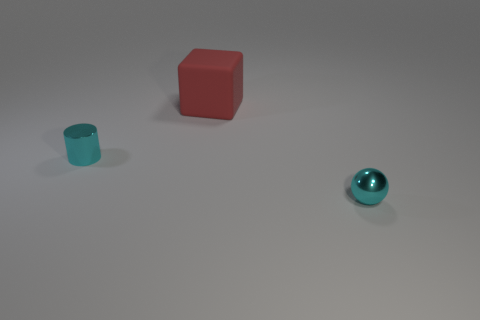Subtract 1 cylinders. How many cylinders are left? 0 Add 1 yellow metal balls. How many objects exist? 4 Subtract all cyan things. Subtract all small cylinders. How many objects are left? 0 Add 3 cyan metal spheres. How many cyan metal spheres are left? 4 Add 1 red rubber objects. How many red rubber objects exist? 2 Subtract 0 yellow balls. How many objects are left? 3 Subtract all cylinders. How many objects are left? 2 